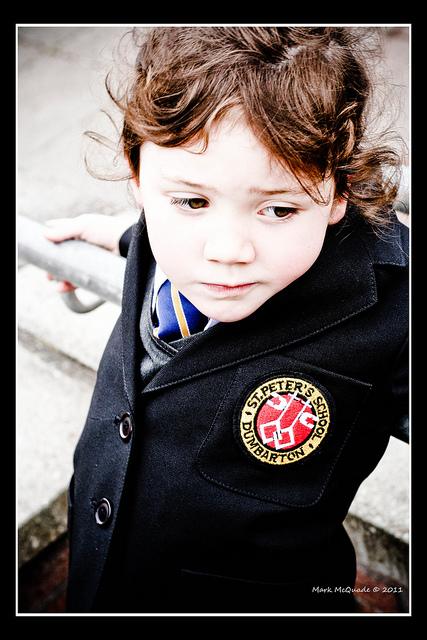Is this person inside or outside?
Write a very short answer. Outside. What school does the child attend?
Keep it brief. St peter's school. Is this a boy or a girl?
Concise answer only. Boy. 